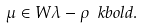<formula> <loc_0><loc_0><loc_500><loc_500>\mu \in W \lambda - \rho _ { \ } k b o l d .</formula> 